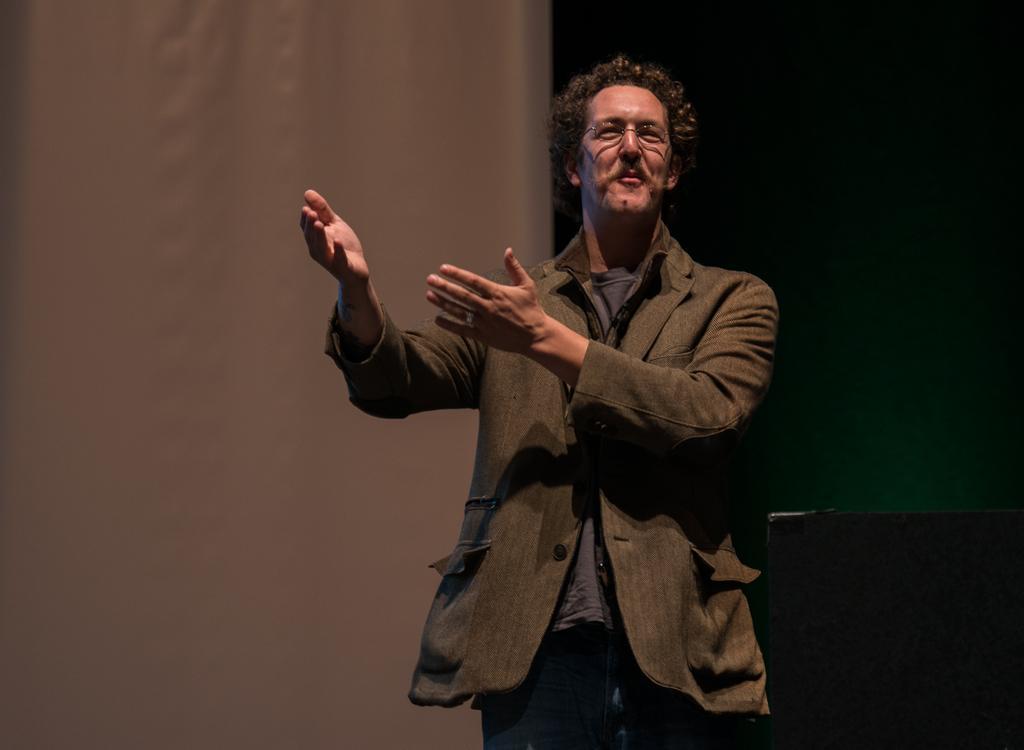Please provide a concise description of this image. In this image I can see the person wearing the dress and specs. In the background I can see the white and green color background. I can see the black color object to the right. 